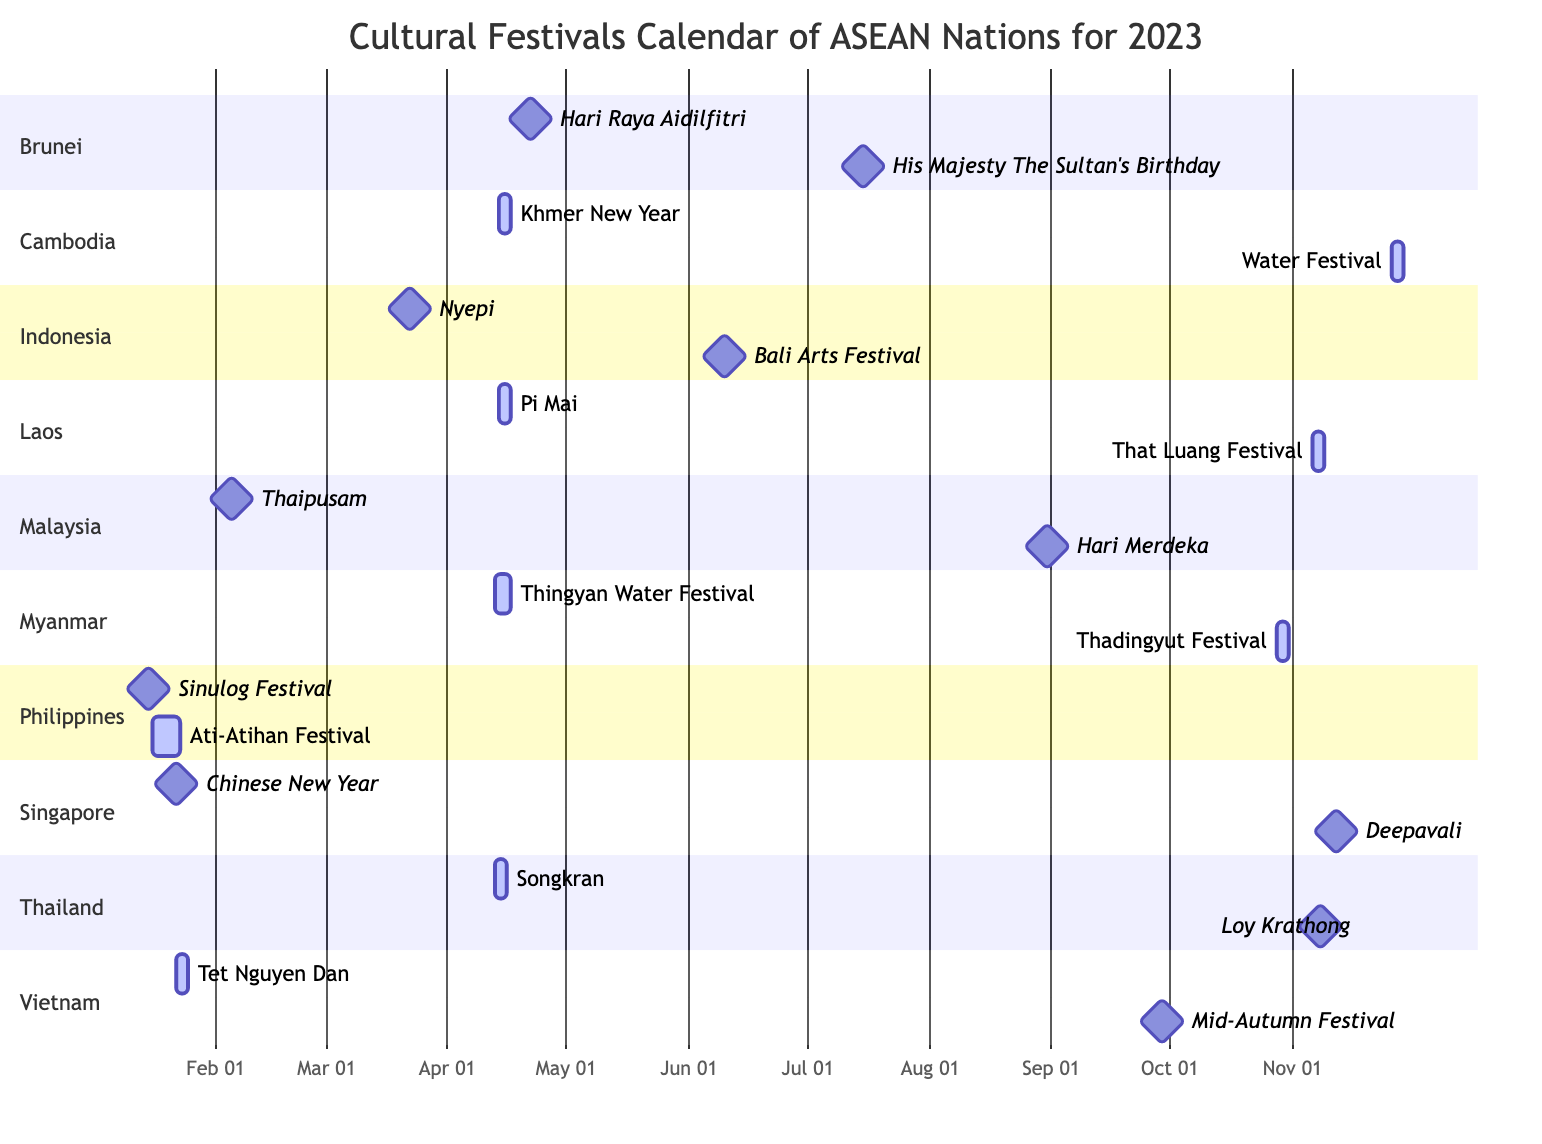What are the two cultural festivals celebrated in Cambodia? From the diagram, Cambodia has two listed cultural festivals: Khmer New Year and Water Festival. These festivals are indicated in the Cambodia section of the diagram.
Answer: Khmer New Year, Water Festival When is the Thai festival Songkran celebrated? By looking at the diagram, the Songkran festival is scheduled for April 13, 2023. This date is shown next to the festival's name under the Thailand section.
Answer: April 13 Which country celebrates the Deepavali festival in 2023? The diagram indicates that the Deepavali festival is celebrated in Singapore, as it is listed under the Singapore section with its date noted.
Answer: Singapore How many festivals are active in Myanmar in 2023? The diagram shows that there are two active festivals in Myanmar for the year 2023: Thingyan Water Festival and Thadingyut Festival. This total is derived by counting the active indicators in the Myanmar section.
Answer: 2 Which festival follows the Chinese New Year in Singapore? By examining the Singapore section, Deepavali follows the Chinese New Year, occurring on November 12, which is after the Chinese New Year on January 22.
Answer: Deepavali What is the duration of the Khmer New Year festival in Cambodia? The Khmer New Year festival lasts for 3 days, as indicated in the description of the festival in the Cambodia section of the diagram.
Answer: 3 days Which country has the earliest cultural festival listed in the calendar? The diagram shows that the earliest festival in the 2023 calendar is the Sinulog Festival in the Philippines on January 15, 2023, marking it as the first event.
Answer: Philippines What festival in Laos takes place in November? According to the diagram, the That Luang Festival takes place in November, specifically on November 6, 2023, as noted in the Laos section.
Answer: That Luang Festival How many milestone festivals occur in Indonesia in 2023? In the Indonesia section of the diagram, there are two milestone festivals listed: Nyepi and Bali Arts Festival, resulting in a total of two milestone festivals.
Answer: 2 